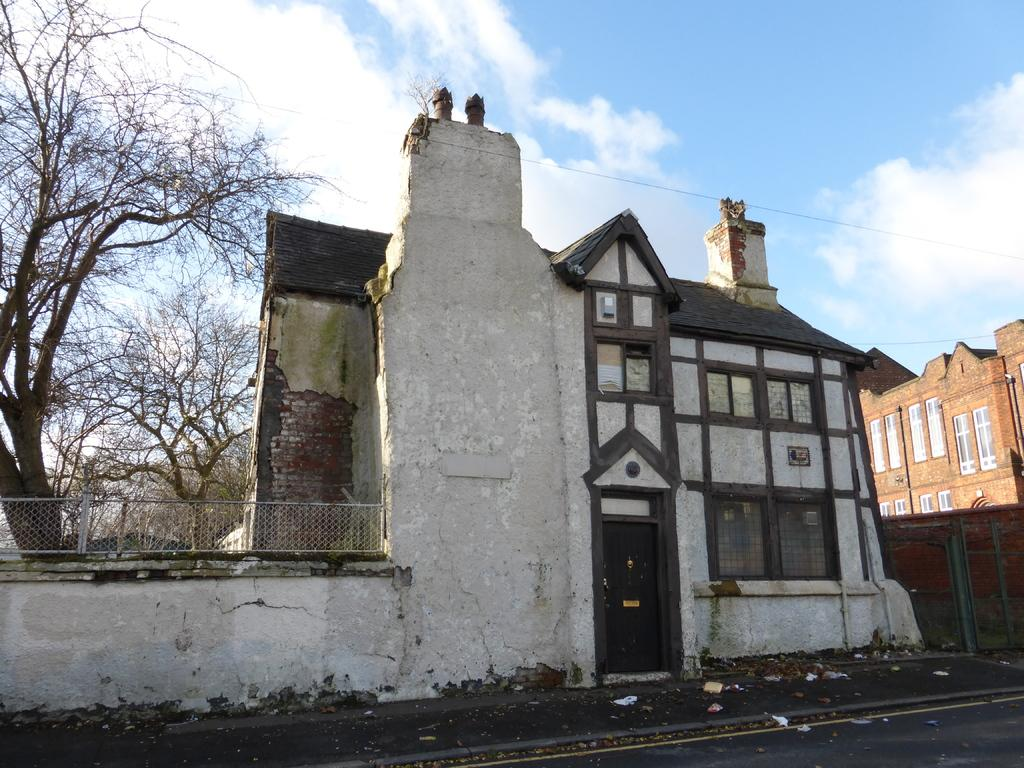What type of pathway is visible in the image? There is a road in the image. What type of structure can be seen near the road? There is a stone wall in the image. What type of entrance is present in the image? There is a door in the image. What type of vegetation is present in the image? There are dry trees in the image. What type of buildings are visible in the image? There are houses in the image. What type of utility is present in the image? There is a wire in the image. What can be seen in the background of the image? The sky is blue, and there are clouds in the background. Where is the basketball court located in the image? There is no basketball court present in the image. Can you describe the kiss between the two people in the image? There are no people or kisses depicted in the image. 